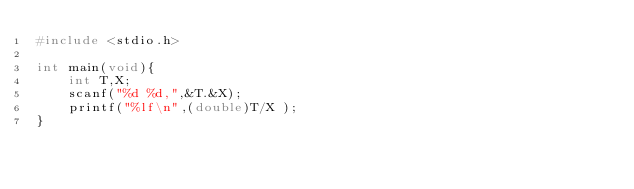Convert code to text. <code><loc_0><loc_0><loc_500><loc_500><_C_>#include <stdio.h>

int main(void){
	int T,X;
	scanf("%d %d,",&T.&X);
	printf("%lf\n",(double)T/X );
}</code> 